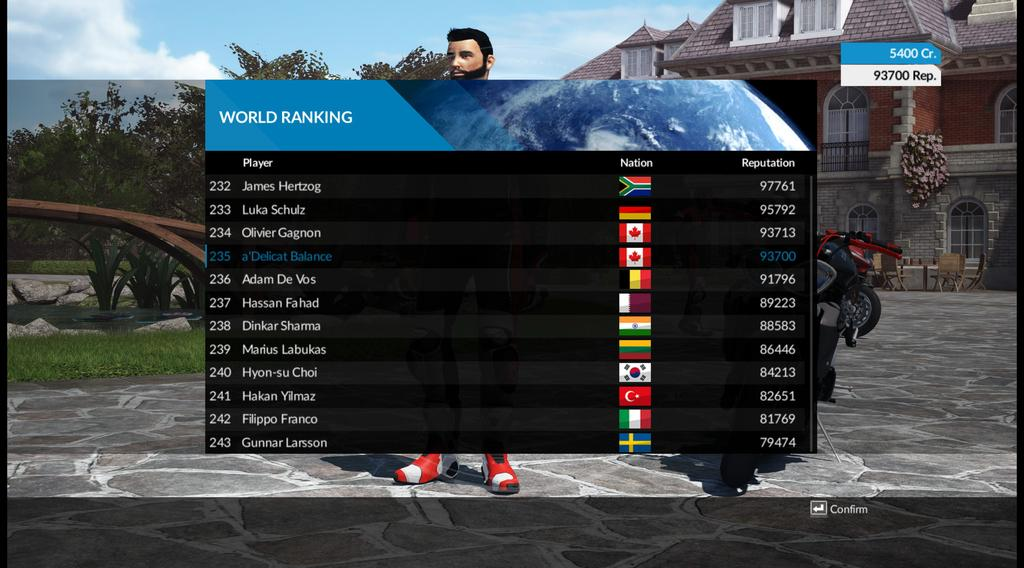<image>
Offer a succinct explanation of the picture presented. A video game screen displays the World Ranking stats of players. 